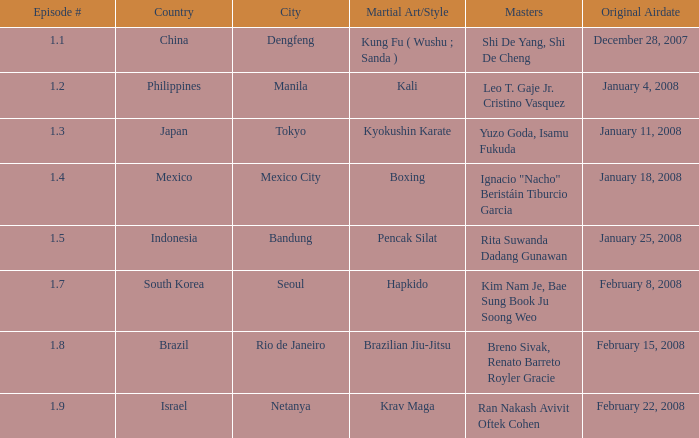When was the episode showcasing a master practicing brazilian jiu-jitsu broadcasted? February 15, 2008. 